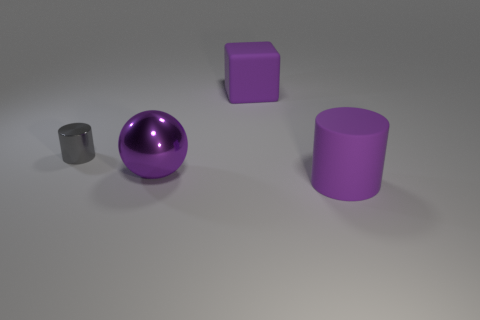Is the lighting in the image casting any interesting shadows or reflections? The lighting creates subtle shadows beneath each object, with the shiny purple sphere reflecting some of the light, giving it a glossy appearance. The matte surfaces of the other objects diffuse the light and do not reflect it, resulting in soft shadows with less contrast. 